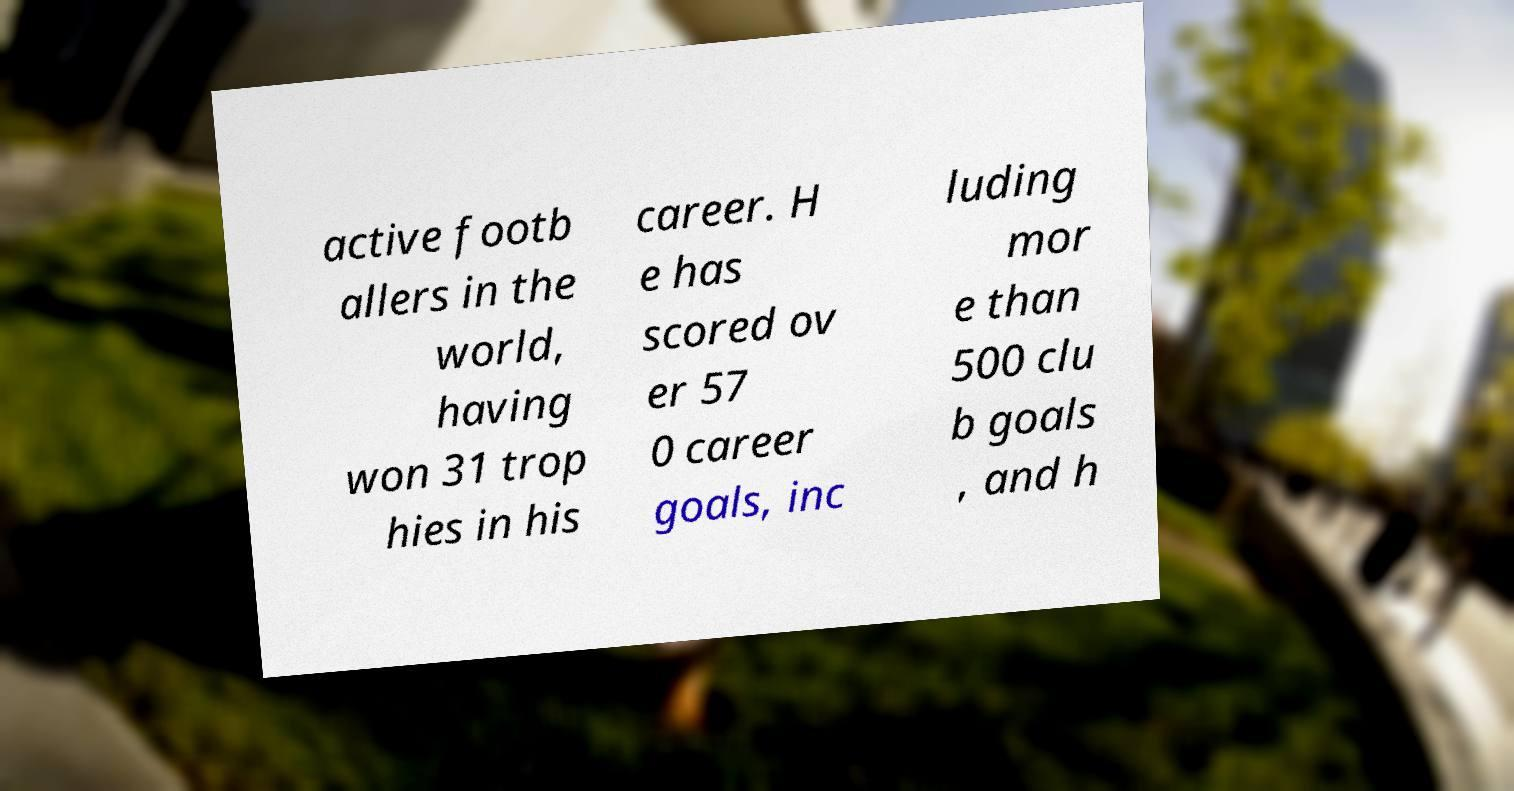Please read and relay the text visible in this image. What does it say? active footb allers in the world, having won 31 trop hies in his career. H e has scored ov er 57 0 career goals, inc luding mor e than 500 clu b goals , and h 